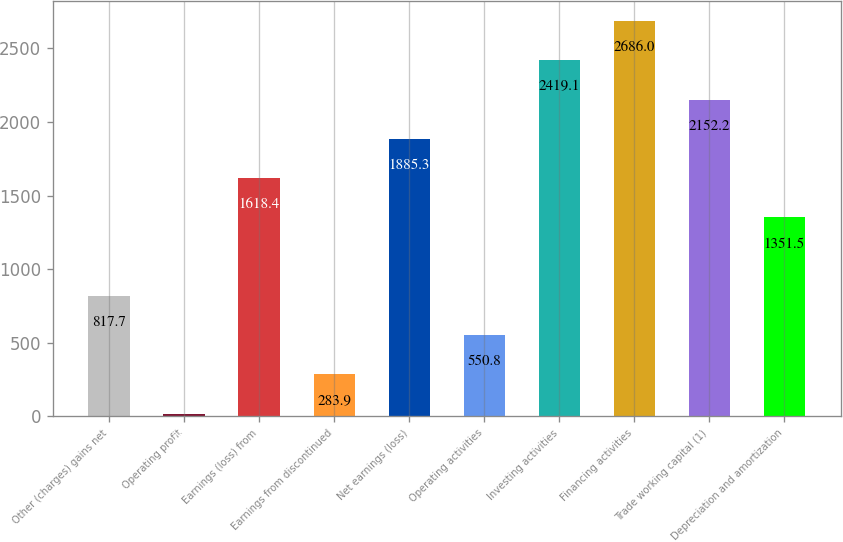Convert chart to OTSL. <chart><loc_0><loc_0><loc_500><loc_500><bar_chart><fcel>Other (charges) gains net<fcel>Operating profit<fcel>Earnings (loss) from<fcel>Earnings from discontinued<fcel>Net earnings (loss)<fcel>Operating activities<fcel>Investing activities<fcel>Financing activities<fcel>Trade working capital (1)<fcel>Depreciation and amortization<nl><fcel>817.7<fcel>17<fcel>1618.4<fcel>283.9<fcel>1885.3<fcel>550.8<fcel>2419.1<fcel>2686<fcel>2152.2<fcel>1351.5<nl></chart> 